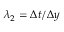Convert formula to latex. <formula><loc_0><loc_0><loc_500><loc_500>\lambda _ { 2 } = \Delta t / \Delta y</formula> 